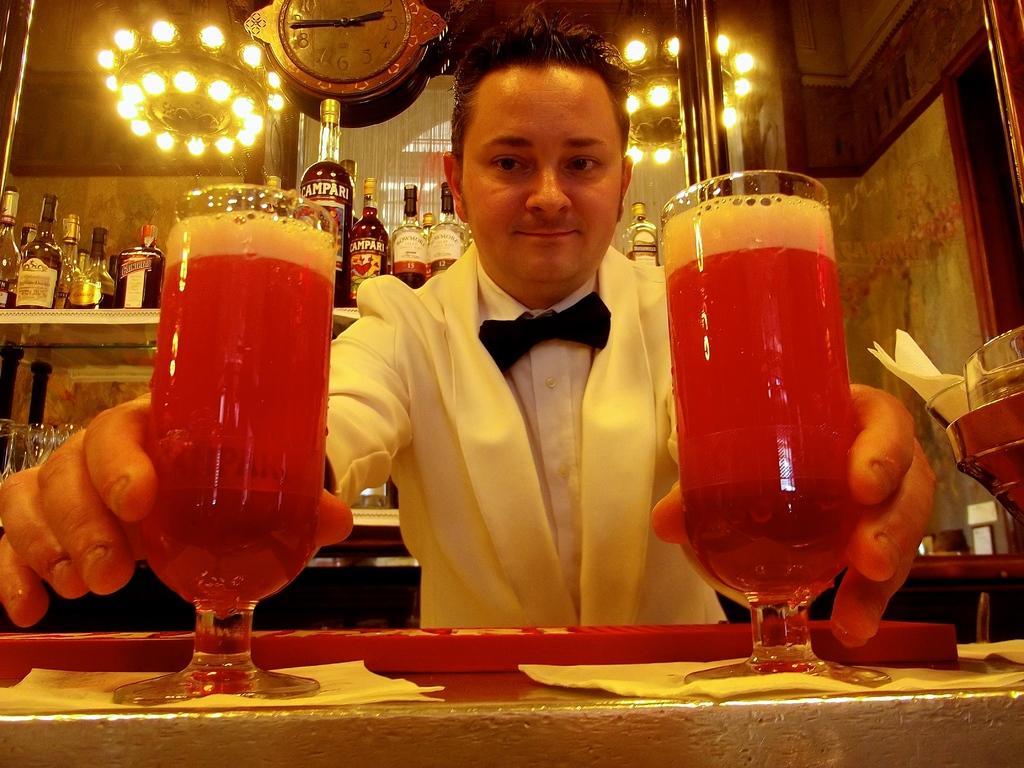Can you describe this image briefly? In this picture there is a man who is wearing white dress and holding two wine glasses. At the bottom I can see the table and tissue papers. In the back I can see the wine bottles and glasses. At the top I can see the wall clock which is placed on the wall. Beside that I can see the chandeliers. 